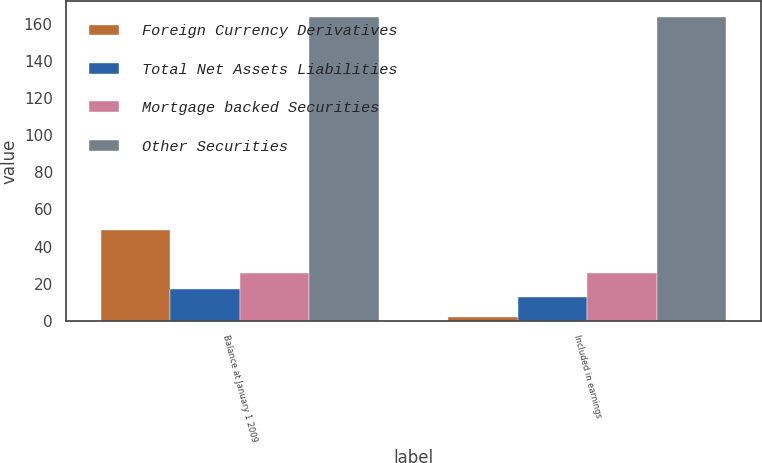<chart> <loc_0><loc_0><loc_500><loc_500><stacked_bar_chart><ecel><fcel>Balance at January 1 2009<fcel>Included in earnings<nl><fcel>Foreign Currency Derivatives<fcel>49<fcel>2<nl><fcel>Total Net Assets Liabilities<fcel>17<fcel>13<nl><fcel>Mortgage backed Securities<fcel>26<fcel>26<nl><fcel>Other Securities<fcel>164<fcel>164<nl></chart> 